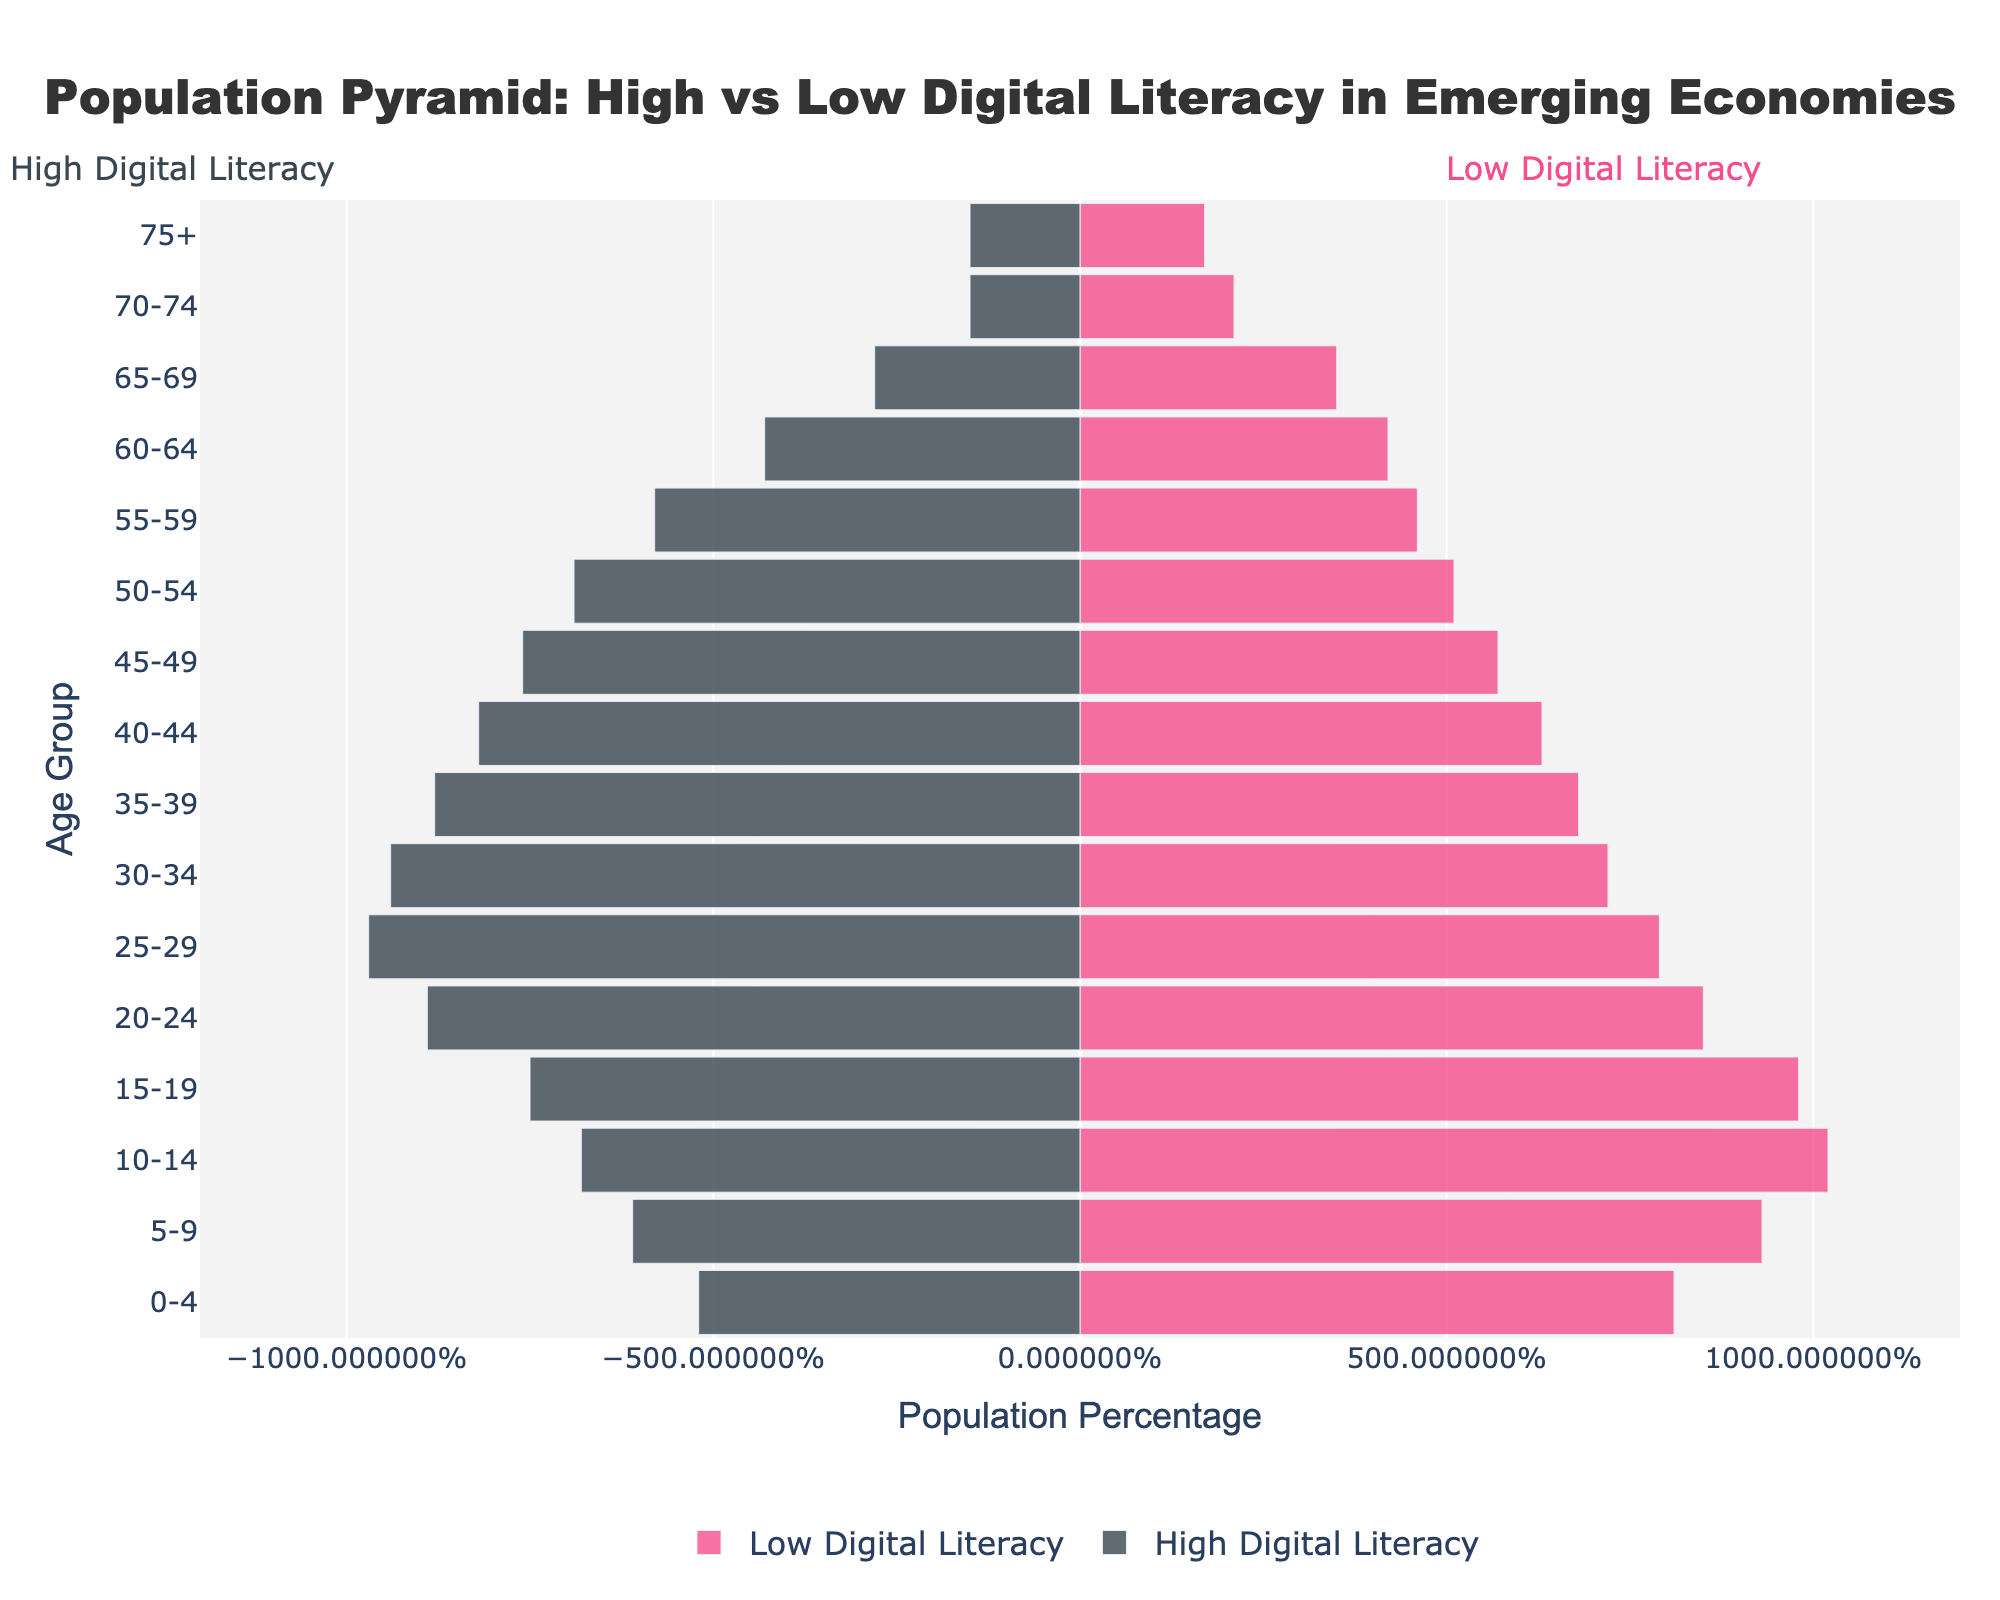What does the title of the figure indicate? The title of the figure is "Population Pyramid: High vs Low Digital Literacy in Emerging Economies." This indicates that the figure shows a comparison of population age structures between groups with high and low digital literacy in emerging economies.
Answer: Population Pyramid: High vs Low Digital Literacy in Emerging Economies Which age group has the highest percentage of high digital literacy? According to the figure, the 25-29 age group has the highest percentage of high digital literacy at 9.7%.
Answer: 25-29 What are the colors representing high and low digital literacy groups? In the figure, high digital literacy is represented by dark gray bars, and low digital literacy is represented by magenta bars.
Answer: Dark gray and magenta In the 20-24 age group, which digital literacy group has a higher percentage? The 20-24 age group has a higher percentage of high digital literacy at 8.9%, compared to 8.5% for low digital literacy.
Answer: High digital literacy What is the difference in the percentage of the population for the 65-69 age group between high and low digital literacy? The percentage for high digital literacy in the 65-69 age group is 2.8%, and for low digital literacy, it is 3.5%. The difference is 3.5% - 2.8% = 0.7%.
Answer: 0.7% Which age group shows the smallest difference between high and low digital literacy rates? The 60-64 age group shows the smallest difference, with 4.3% for high digital literacy and 4.2% for low digital literacy, giving a difference of 0.1%.
Answer: 60-64 How does the population percentage with low digital literacy change across age groups? The population percentage with low digital literacy generally decreases with increasing age, starting from 8.1% in the 0-4 age group to 1.7% in the 75+ age group.
Answer: Generally decreases Which age group has a lower percentage of low digital literacy compared to high digital literacy? Several age groups have a lower percentage of low digital literacy compared to high digital literacy, but one example is the 25-29 age group, with 7.9% low digital literacy compared to 9.7% high digital literacy.
Answer: 25-29 What is the percentage of population aged 75+ with high digital literacy? The percentage of the population aged 75+ with high digital literacy is 1.5%.
Answer: 1.5% Is the proportion of the population with high digital literacy generally larger in younger or older age groups? The proportion of the population with high digital literacy is generally larger in younger age groups and decreases as age increases.
Answer: Younger age groups 